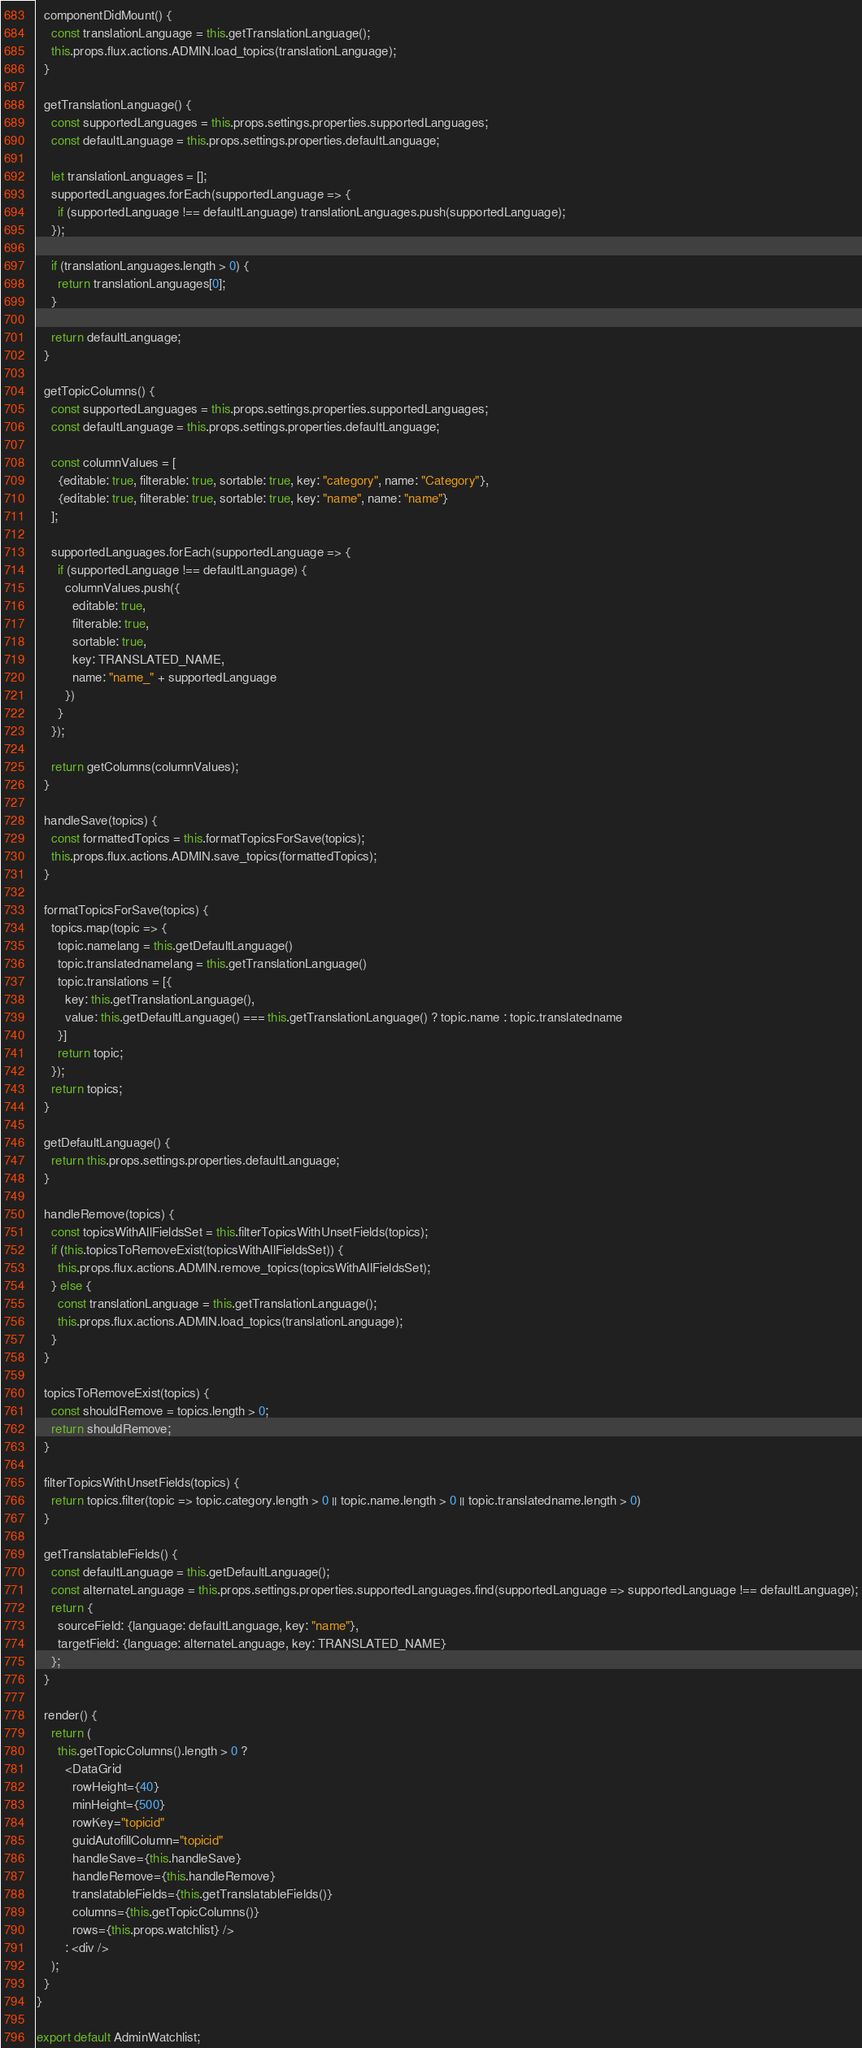<code> <loc_0><loc_0><loc_500><loc_500><_JavaScript_>  componentDidMount() {
    const translationLanguage = this.getTranslationLanguage();
    this.props.flux.actions.ADMIN.load_topics(translationLanguage);
  }

  getTranslationLanguage() {
    const supportedLanguages = this.props.settings.properties.supportedLanguages;
    const defaultLanguage = this.props.settings.properties.defaultLanguage;

    let translationLanguages = [];
    supportedLanguages.forEach(supportedLanguage => {
      if (supportedLanguage !== defaultLanguage) translationLanguages.push(supportedLanguage);
    });

    if (translationLanguages.length > 0) {
      return translationLanguages[0];
    }

    return defaultLanguage;
  }

  getTopicColumns() {
    const supportedLanguages = this.props.settings.properties.supportedLanguages;
    const defaultLanguage = this.props.settings.properties.defaultLanguage;

    const columnValues = [
      {editable: true, filterable: true, sortable: true, key: "category", name: "Category"},
      {editable: true, filterable: true, sortable: true, key: "name", name: "name"}
    ];

    supportedLanguages.forEach(supportedLanguage => {
      if (supportedLanguage !== defaultLanguage) {
        columnValues.push({
          editable: true,
          filterable: true,
          sortable: true,
          key: TRANSLATED_NAME,
          name: "name_" + supportedLanguage
        })
      }
    });

    return getColumns(columnValues);
  }

  handleSave(topics) {
    const formattedTopics = this.formatTopicsForSave(topics);
    this.props.flux.actions.ADMIN.save_topics(formattedTopics);
  }

  formatTopicsForSave(topics) {
    topics.map(topic => {
      topic.namelang = this.getDefaultLanguage()
      topic.translatednamelang = this.getTranslationLanguage()
      topic.translations = [{
        key: this.getTranslationLanguage(),
        value: this.getDefaultLanguage() === this.getTranslationLanguage() ? topic.name : topic.translatedname 
      }]
      return topic;
    });
    return topics;
  }

  getDefaultLanguage() {
    return this.props.settings.properties.defaultLanguage;
  }

  handleRemove(topics) {
    const topicsWithAllFieldsSet = this.filterTopicsWithUnsetFields(topics);
    if (this.topicsToRemoveExist(topicsWithAllFieldsSet)) {
      this.props.flux.actions.ADMIN.remove_topics(topicsWithAllFieldsSet);
    } else {
      const translationLanguage = this.getTranslationLanguage();
      this.props.flux.actions.ADMIN.load_topics(translationLanguage);
    }
  }

  topicsToRemoveExist(topics) {
    const shouldRemove = topics.length > 0;
    return shouldRemove;
  }

  filterTopicsWithUnsetFields(topics) {
    return topics.filter(topic => topic.category.length > 0 || topic.name.length > 0 || topic.translatedname.length > 0)
  }

  getTranslatableFields() {
    const defaultLanguage = this.getDefaultLanguage();
    const alternateLanguage = this.props.settings.properties.supportedLanguages.find(supportedLanguage => supportedLanguage !== defaultLanguage);
    return {
      sourceField: {language: defaultLanguage, key: "name"},
      targetField: {language: alternateLanguage, key: TRANSLATED_NAME}
    };
  }

  render() {
    return (
      this.getTopicColumns().length > 0 ?
        <DataGrid
          rowHeight={40}
          minHeight={500}
          rowKey="topicid"
          guidAutofillColumn="topicid"
          handleSave={this.handleSave}
          handleRemove={this.handleRemove}
          translatableFields={this.getTranslatableFields()}
          columns={this.getTopicColumns()}
          rows={this.props.watchlist} />
        : <div />
    );
  }
}

export default AdminWatchlist;</code> 